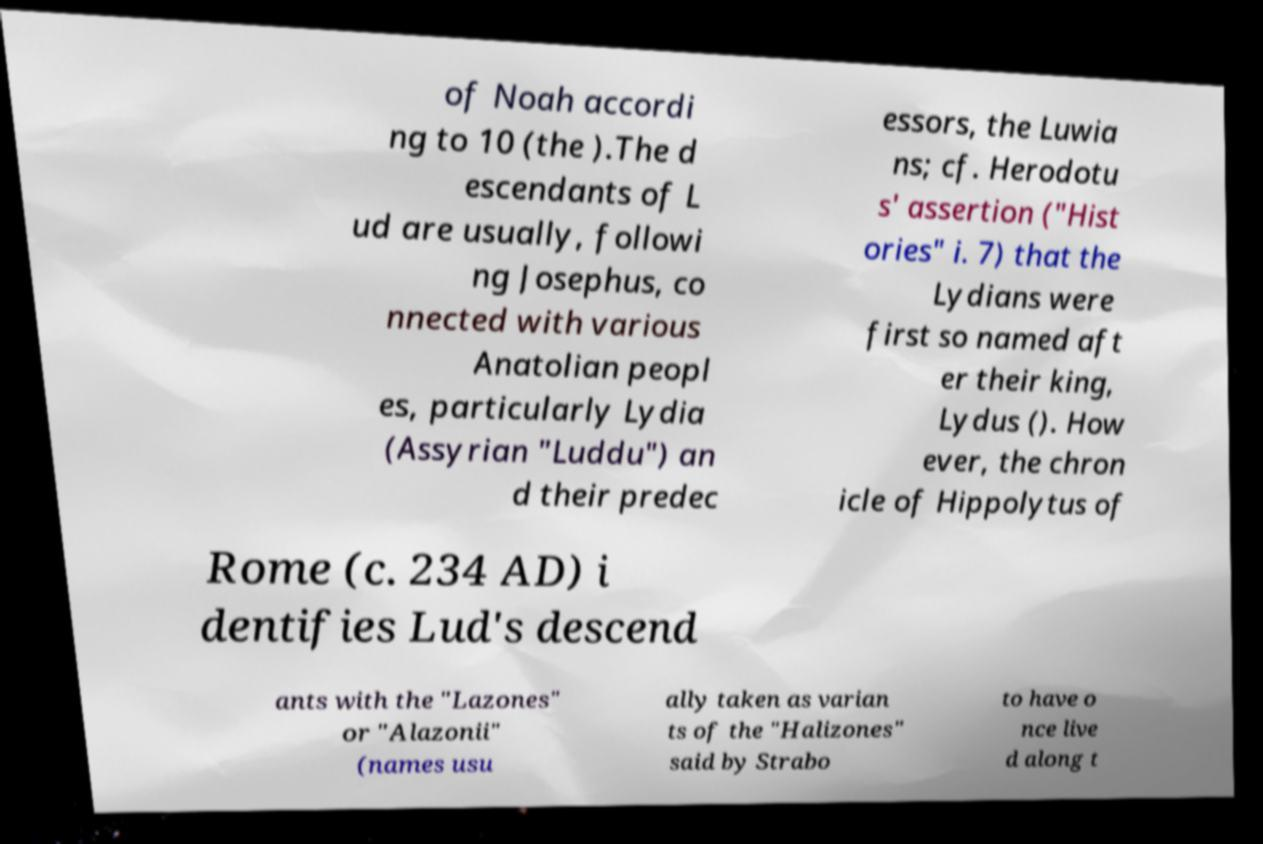For documentation purposes, I need the text within this image transcribed. Could you provide that? of Noah accordi ng to 10 (the ).The d escendants of L ud are usually, followi ng Josephus, co nnected with various Anatolian peopl es, particularly Lydia (Assyrian "Luddu") an d their predec essors, the Luwia ns; cf. Herodotu s' assertion ("Hist ories" i. 7) that the Lydians were first so named aft er their king, Lydus (). How ever, the chron icle of Hippolytus of Rome (c. 234 AD) i dentifies Lud's descend ants with the "Lazones" or "Alazonii" (names usu ally taken as varian ts of the "Halizones" said by Strabo to have o nce live d along t 